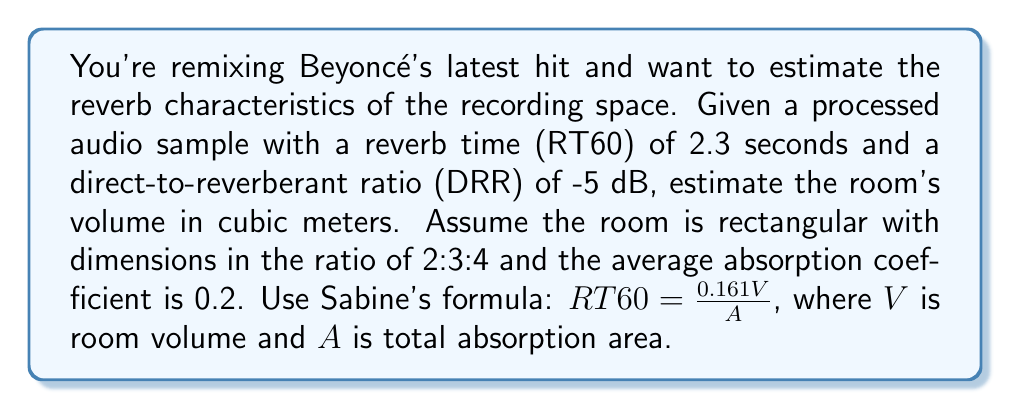Show me your answer to this math problem. 1. Start with Sabine's formula: $RT60 = \frac{0.161V}{A}$

2. Rearrange to solve for $A$: $A = \frac{0.161V}{RT60}$

3. The total absorption area $A$ is related to the room's surface area $S$ and average absorption coefficient $\alpha$: $A = \alpha S$

4. For a rectangular room with dimensions in ratio 2:3:4, let the shortest dimension be $x$. Then:
   Volume: $V = 2x \cdot 3x \cdot 4x = 24x^3$
   Surface area: $S = 2(2x \cdot 3x + 2x \cdot 4x + 3x \cdot 4x) = 52x^2$

5. Substitute these into the equation from step 2:
   $\alpha S = \frac{0.161V}{RT60}$
   $0.2 \cdot 52x^2 = \frac{0.161 \cdot 24x^3}{2.3}$

6. Simplify:
   $10.4x^2 = 1.68x^3$
   $x = 6.19$ meters

7. Calculate the volume:
   $V = 24x^3 = 24 \cdot 6.19^3 = 5690.5$ cubic meters

8. Round to the nearest whole number: 5691 cubic meters
Answer: 5691 m³ 